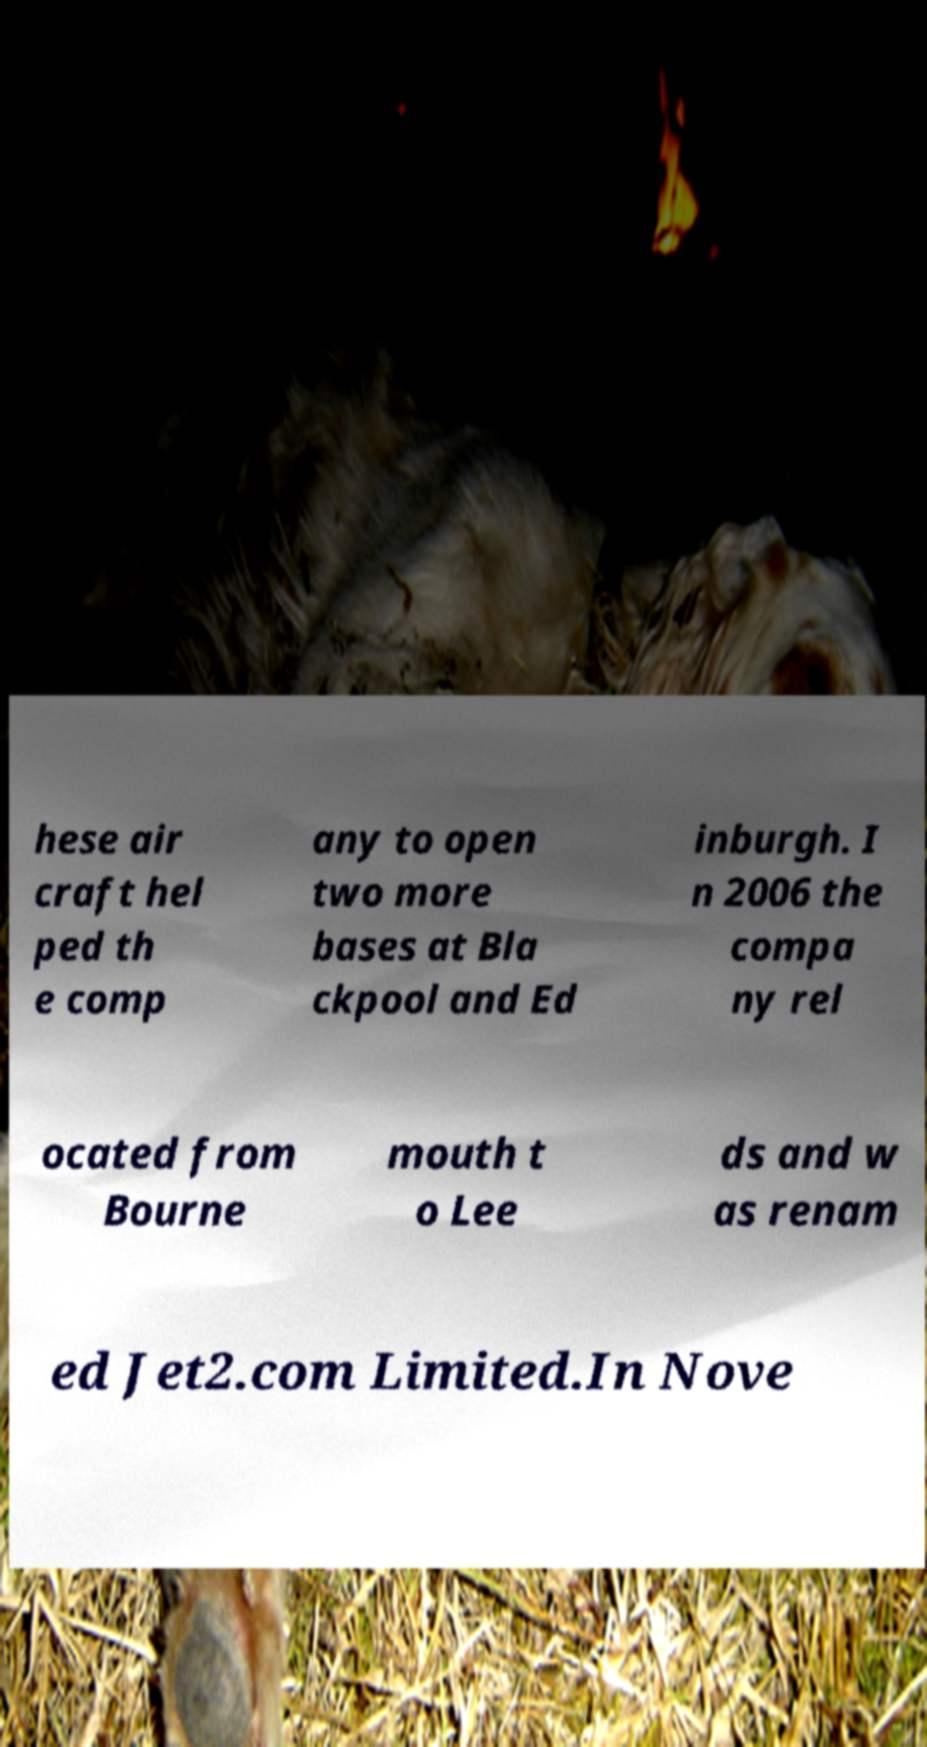There's text embedded in this image that I need extracted. Can you transcribe it verbatim? hese air craft hel ped th e comp any to open two more bases at Bla ckpool and Ed inburgh. I n 2006 the compa ny rel ocated from Bourne mouth t o Lee ds and w as renam ed Jet2.com Limited.In Nove 